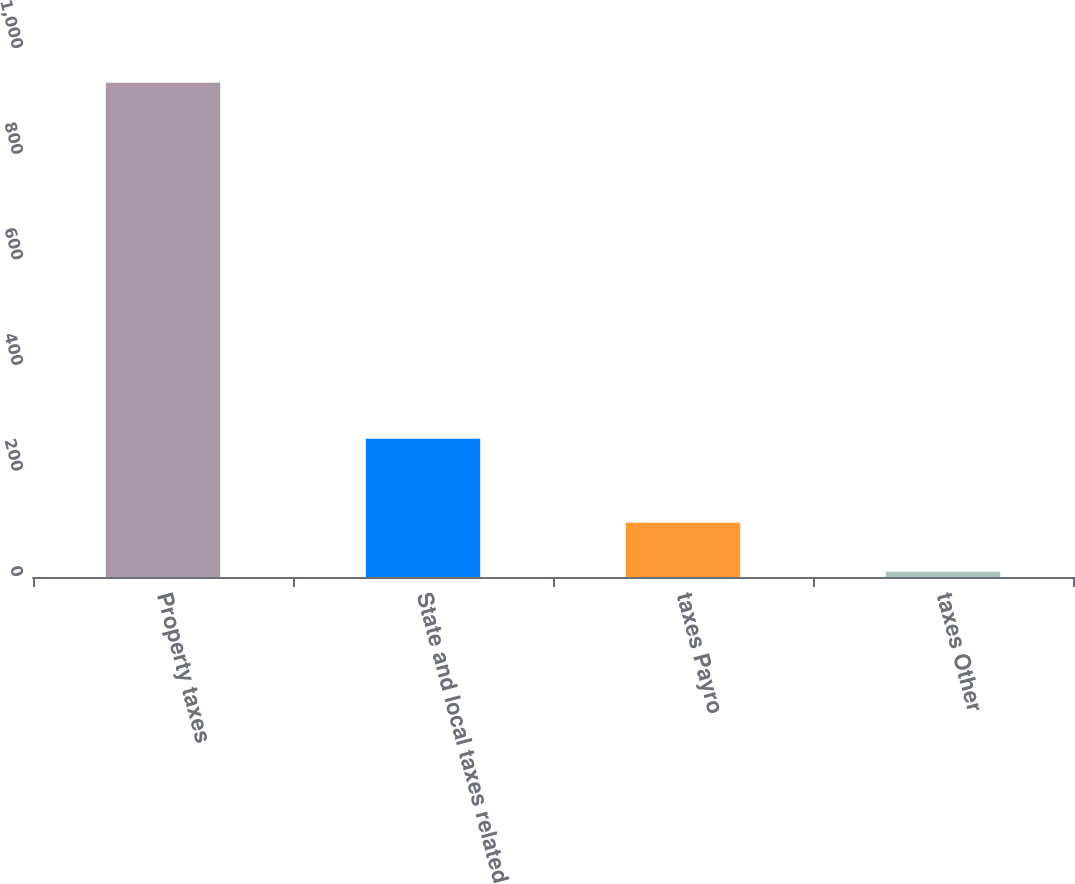Convert chart. <chart><loc_0><loc_0><loc_500><loc_500><bar_chart><fcel>Property taxes<fcel>State and local taxes related<fcel>taxes Payro<fcel>taxes Other<nl><fcel>936<fcel>262<fcel>102.6<fcel>10<nl></chart> 